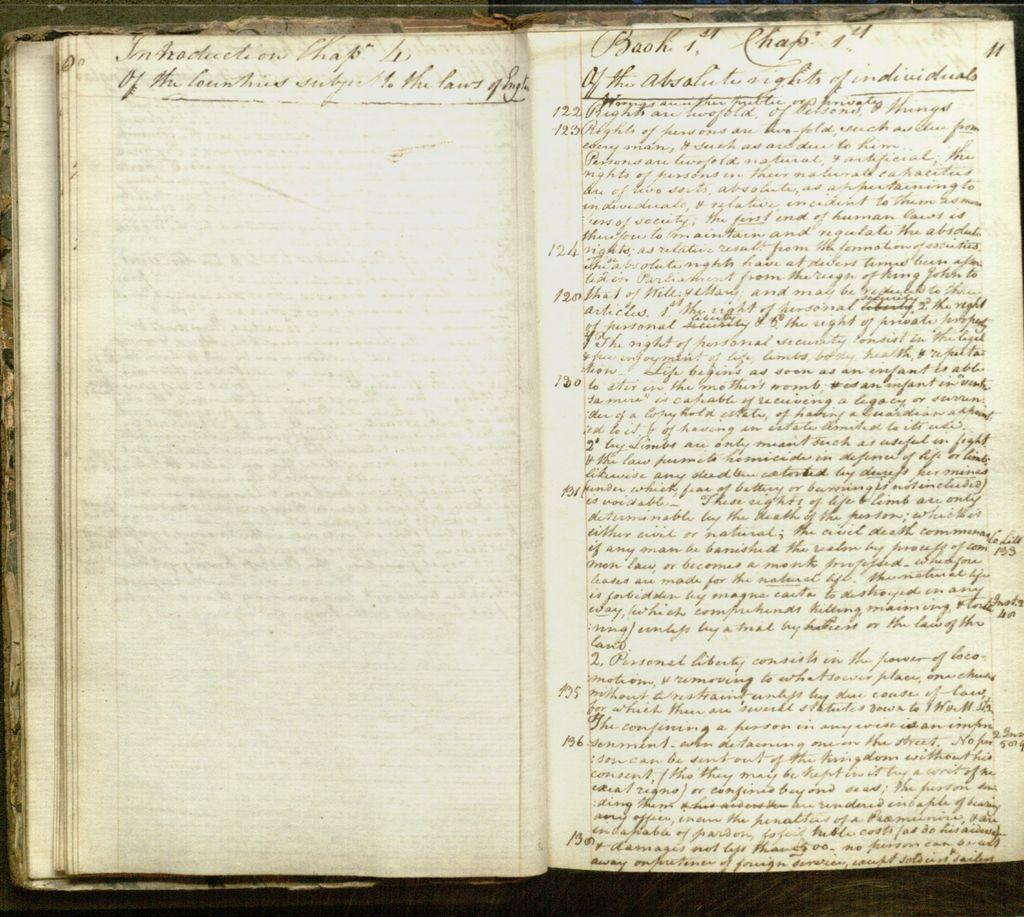<image>
Write a terse but informative summary of the picture. a series of things written on a book with the word 'book' written at the top 